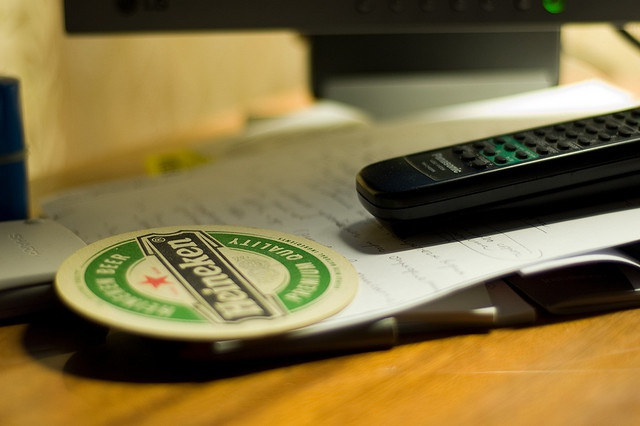Describe the objects in this image and their specific colors. I can see a remote in tan, black, darkgreen, and gray tones in this image. 